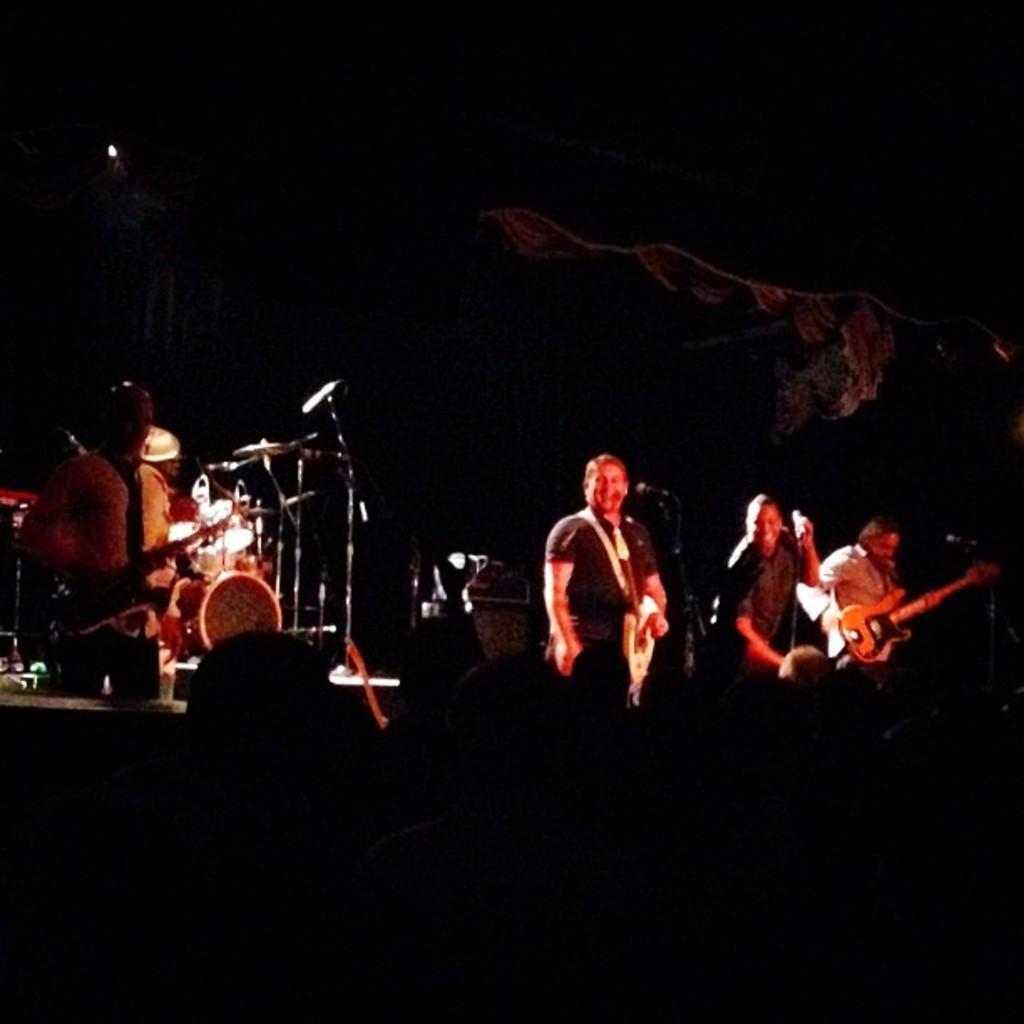Could you give a brief overview of what you see in this image? This picture is clicked in musical concert. On the right corner, we see three men holding guitar and playing it. On the left corner, we see two men playing drums. This picture is taken in dark room. 